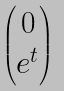Convert formula to latex. <formula><loc_0><loc_0><loc_500><loc_500>\begin{pmatrix} 0 \\ e ^ { t } \end{pmatrix}</formula> 